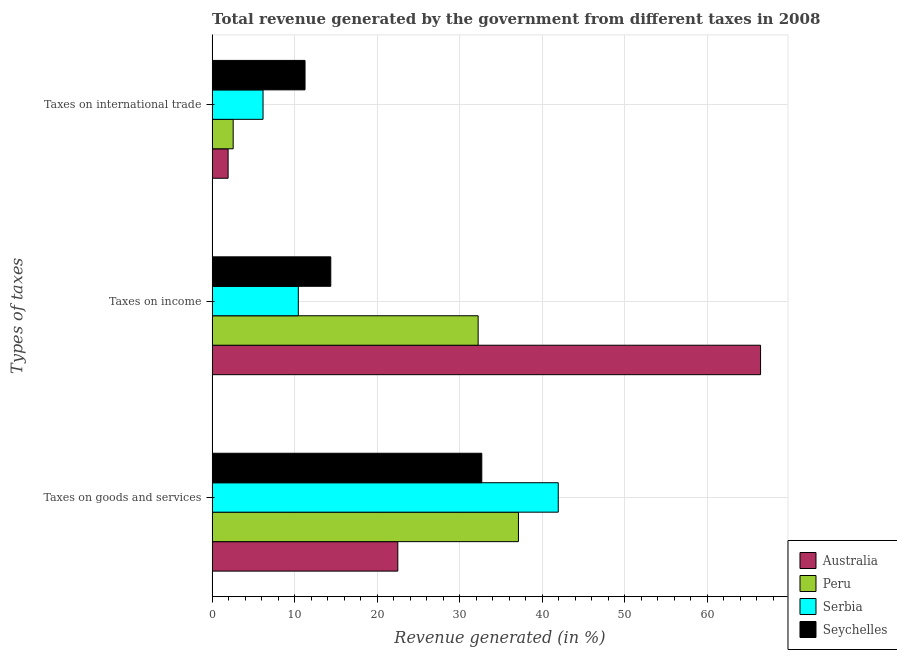How many groups of bars are there?
Your answer should be compact. 3. How many bars are there on the 2nd tick from the top?
Provide a short and direct response. 4. How many bars are there on the 2nd tick from the bottom?
Offer a terse response. 4. What is the label of the 3rd group of bars from the top?
Offer a very short reply. Taxes on goods and services. What is the percentage of revenue generated by tax on international trade in Australia?
Your answer should be very brief. 1.94. Across all countries, what is the maximum percentage of revenue generated by taxes on goods and services?
Ensure brevity in your answer.  41.95. Across all countries, what is the minimum percentage of revenue generated by tax on international trade?
Offer a very short reply. 1.94. In which country was the percentage of revenue generated by tax on international trade maximum?
Your response must be concise. Seychelles. In which country was the percentage of revenue generated by tax on international trade minimum?
Your answer should be compact. Australia. What is the total percentage of revenue generated by taxes on income in the graph?
Ensure brevity in your answer.  123.55. What is the difference between the percentage of revenue generated by taxes on income in Seychelles and that in Serbia?
Your response must be concise. 3.93. What is the difference between the percentage of revenue generated by taxes on goods and services in Peru and the percentage of revenue generated by taxes on income in Seychelles?
Keep it short and to the point. 22.75. What is the average percentage of revenue generated by taxes on income per country?
Offer a very short reply. 30.89. What is the difference between the percentage of revenue generated by taxes on income and percentage of revenue generated by taxes on goods and services in Serbia?
Your answer should be very brief. -31.51. In how many countries, is the percentage of revenue generated by taxes on income greater than 56 %?
Your answer should be very brief. 1. What is the ratio of the percentage of revenue generated by taxes on goods and services in Australia to that in Peru?
Offer a terse response. 0.61. Is the percentage of revenue generated by tax on international trade in Serbia less than that in Seychelles?
Make the answer very short. Yes. What is the difference between the highest and the second highest percentage of revenue generated by tax on international trade?
Provide a succinct answer. 5.09. What is the difference between the highest and the lowest percentage of revenue generated by taxes on goods and services?
Your response must be concise. 19.45. Is the sum of the percentage of revenue generated by taxes on income in Peru and Serbia greater than the maximum percentage of revenue generated by tax on international trade across all countries?
Make the answer very short. Yes. What does the 2nd bar from the top in Taxes on income represents?
Offer a very short reply. Serbia. What does the 1st bar from the bottom in Taxes on income represents?
Make the answer very short. Australia. What is the difference between two consecutive major ticks on the X-axis?
Make the answer very short. 10. Does the graph contain any zero values?
Provide a succinct answer. No. How many legend labels are there?
Your response must be concise. 4. How are the legend labels stacked?
Ensure brevity in your answer.  Vertical. What is the title of the graph?
Ensure brevity in your answer.  Total revenue generated by the government from different taxes in 2008. Does "Korea (Republic)" appear as one of the legend labels in the graph?
Ensure brevity in your answer.  No. What is the label or title of the X-axis?
Your answer should be compact. Revenue generated (in %). What is the label or title of the Y-axis?
Your answer should be compact. Types of taxes. What is the Revenue generated (in %) of Australia in Taxes on goods and services?
Give a very brief answer. 22.51. What is the Revenue generated (in %) of Peru in Taxes on goods and services?
Your answer should be compact. 37.13. What is the Revenue generated (in %) in Serbia in Taxes on goods and services?
Make the answer very short. 41.95. What is the Revenue generated (in %) in Seychelles in Taxes on goods and services?
Give a very brief answer. 32.69. What is the Revenue generated (in %) of Australia in Taxes on income?
Your answer should be compact. 66.48. What is the Revenue generated (in %) of Peru in Taxes on income?
Keep it short and to the point. 32.24. What is the Revenue generated (in %) of Serbia in Taxes on income?
Provide a short and direct response. 10.45. What is the Revenue generated (in %) of Seychelles in Taxes on income?
Give a very brief answer. 14.38. What is the Revenue generated (in %) of Australia in Taxes on international trade?
Your answer should be very brief. 1.94. What is the Revenue generated (in %) of Peru in Taxes on international trade?
Keep it short and to the point. 2.55. What is the Revenue generated (in %) of Serbia in Taxes on international trade?
Ensure brevity in your answer.  6.17. What is the Revenue generated (in %) in Seychelles in Taxes on international trade?
Your response must be concise. 11.26. Across all Types of taxes, what is the maximum Revenue generated (in %) in Australia?
Keep it short and to the point. 66.48. Across all Types of taxes, what is the maximum Revenue generated (in %) in Peru?
Offer a very short reply. 37.13. Across all Types of taxes, what is the maximum Revenue generated (in %) of Serbia?
Make the answer very short. 41.95. Across all Types of taxes, what is the maximum Revenue generated (in %) of Seychelles?
Provide a short and direct response. 32.69. Across all Types of taxes, what is the minimum Revenue generated (in %) of Australia?
Your answer should be very brief. 1.94. Across all Types of taxes, what is the minimum Revenue generated (in %) in Peru?
Provide a succinct answer. 2.55. Across all Types of taxes, what is the minimum Revenue generated (in %) of Serbia?
Offer a very short reply. 6.17. Across all Types of taxes, what is the minimum Revenue generated (in %) of Seychelles?
Make the answer very short. 11.26. What is the total Revenue generated (in %) in Australia in the graph?
Make the answer very short. 90.92. What is the total Revenue generated (in %) in Peru in the graph?
Your answer should be very brief. 71.92. What is the total Revenue generated (in %) of Serbia in the graph?
Give a very brief answer. 58.58. What is the total Revenue generated (in %) of Seychelles in the graph?
Make the answer very short. 58.33. What is the difference between the Revenue generated (in %) of Australia in Taxes on goods and services and that in Taxes on income?
Your answer should be compact. -43.97. What is the difference between the Revenue generated (in %) of Peru in Taxes on goods and services and that in Taxes on income?
Ensure brevity in your answer.  4.89. What is the difference between the Revenue generated (in %) of Serbia in Taxes on goods and services and that in Taxes on income?
Your answer should be very brief. 31.51. What is the difference between the Revenue generated (in %) in Seychelles in Taxes on goods and services and that in Taxes on income?
Offer a very short reply. 18.3. What is the difference between the Revenue generated (in %) of Australia in Taxes on goods and services and that in Taxes on international trade?
Your answer should be very brief. 20.57. What is the difference between the Revenue generated (in %) of Peru in Taxes on goods and services and that in Taxes on international trade?
Offer a very short reply. 34.58. What is the difference between the Revenue generated (in %) of Serbia in Taxes on goods and services and that in Taxes on international trade?
Offer a terse response. 35.78. What is the difference between the Revenue generated (in %) in Seychelles in Taxes on goods and services and that in Taxes on international trade?
Your answer should be compact. 21.43. What is the difference between the Revenue generated (in %) of Australia in Taxes on income and that in Taxes on international trade?
Your response must be concise. 64.54. What is the difference between the Revenue generated (in %) in Peru in Taxes on income and that in Taxes on international trade?
Make the answer very short. 29.69. What is the difference between the Revenue generated (in %) of Serbia in Taxes on income and that in Taxes on international trade?
Make the answer very short. 4.28. What is the difference between the Revenue generated (in %) in Seychelles in Taxes on income and that in Taxes on international trade?
Make the answer very short. 3.12. What is the difference between the Revenue generated (in %) in Australia in Taxes on goods and services and the Revenue generated (in %) in Peru in Taxes on income?
Your answer should be very brief. -9.74. What is the difference between the Revenue generated (in %) of Australia in Taxes on goods and services and the Revenue generated (in %) of Serbia in Taxes on income?
Provide a short and direct response. 12.06. What is the difference between the Revenue generated (in %) of Australia in Taxes on goods and services and the Revenue generated (in %) of Seychelles in Taxes on income?
Offer a very short reply. 8.12. What is the difference between the Revenue generated (in %) in Peru in Taxes on goods and services and the Revenue generated (in %) in Serbia in Taxes on income?
Make the answer very short. 26.68. What is the difference between the Revenue generated (in %) of Peru in Taxes on goods and services and the Revenue generated (in %) of Seychelles in Taxes on income?
Ensure brevity in your answer.  22.75. What is the difference between the Revenue generated (in %) in Serbia in Taxes on goods and services and the Revenue generated (in %) in Seychelles in Taxes on income?
Give a very brief answer. 27.57. What is the difference between the Revenue generated (in %) in Australia in Taxes on goods and services and the Revenue generated (in %) in Peru in Taxes on international trade?
Offer a terse response. 19.96. What is the difference between the Revenue generated (in %) of Australia in Taxes on goods and services and the Revenue generated (in %) of Serbia in Taxes on international trade?
Provide a short and direct response. 16.33. What is the difference between the Revenue generated (in %) of Australia in Taxes on goods and services and the Revenue generated (in %) of Seychelles in Taxes on international trade?
Offer a very short reply. 11.25. What is the difference between the Revenue generated (in %) of Peru in Taxes on goods and services and the Revenue generated (in %) of Serbia in Taxes on international trade?
Give a very brief answer. 30.96. What is the difference between the Revenue generated (in %) in Peru in Taxes on goods and services and the Revenue generated (in %) in Seychelles in Taxes on international trade?
Your answer should be compact. 25.87. What is the difference between the Revenue generated (in %) in Serbia in Taxes on goods and services and the Revenue generated (in %) in Seychelles in Taxes on international trade?
Keep it short and to the point. 30.69. What is the difference between the Revenue generated (in %) in Australia in Taxes on income and the Revenue generated (in %) in Peru in Taxes on international trade?
Give a very brief answer. 63.92. What is the difference between the Revenue generated (in %) of Australia in Taxes on income and the Revenue generated (in %) of Serbia in Taxes on international trade?
Provide a succinct answer. 60.3. What is the difference between the Revenue generated (in %) in Australia in Taxes on income and the Revenue generated (in %) in Seychelles in Taxes on international trade?
Offer a very short reply. 55.21. What is the difference between the Revenue generated (in %) of Peru in Taxes on income and the Revenue generated (in %) of Serbia in Taxes on international trade?
Ensure brevity in your answer.  26.07. What is the difference between the Revenue generated (in %) in Peru in Taxes on income and the Revenue generated (in %) in Seychelles in Taxes on international trade?
Offer a very short reply. 20.98. What is the difference between the Revenue generated (in %) in Serbia in Taxes on income and the Revenue generated (in %) in Seychelles in Taxes on international trade?
Your answer should be compact. -0.81. What is the average Revenue generated (in %) of Australia per Types of taxes?
Provide a succinct answer. 30.31. What is the average Revenue generated (in %) of Peru per Types of taxes?
Ensure brevity in your answer.  23.98. What is the average Revenue generated (in %) in Serbia per Types of taxes?
Provide a succinct answer. 19.53. What is the average Revenue generated (in %) in Seychelles per Types of taxes?
Offer a very short reply. 19.44. What is the difference between the Revenue generated (in %) of Australia and Revenue generated (in %) of Peru in Taxes on goods and services?
Make the answer very short. -14.62. What is the difference between the Revenue generated (in %) in Australia and Revenue generated (in %) in Serbia in Taxes on goods and services?
Provide a short and direct response. -19.45. What is the difference between the Revenue generated (in %) of Australia and Revenue generated (in %) of Seychelles in Taxes on goods and services?
Keep it short and to the point. -10.18. What is the difference between the Revenue generated (in %) in Peru and Revenue generated (in %) in Serbia in Taxes on goods and services?
Your answer should be compact. -4.82. What is the difference between the Revenue generated (in %) in Peru and Revenue generated (in %) in Seychelles in Taxes on goods and services?
Make the answer very short. 4.44. What is the difference between the Revenue generated (in %) of Serbia and Revenue generated (in %) of Seychelles in Taxes on goods and services?
Offer a terse response. 9.27. What is the difference between the Revenue generated (in %) of Australia and Revenue generated (in %) of Peru in Taxes on income?
Offer a very short reply. 34.23. What is the difference between the Revenue generated (in %) of Australia and Revenue generated (in %) of Serbia in Taxes on income?
Your response must be concise. 56.03. What is the difference between the Revenue generated (in %) in Australia and Revenue generated (in %) in Seychelles in Taxes on income?
Offer a terse response. 52.09. What is the difference between the Revenue generated (in %) of Peru and Revenue generated (in %) of Serbia in Taxes on income?
Offer a terse response. 21.79. What is the difference between the Revenue generated (in %) in Peru and Revenue generated (in %) in Seychelles in Taxes on income?
Give a very brief answer. 17.86. What is the difference between the Revenue generated (in %) of Serbia and Revenue generated (in %) of Seychelles in Taxes on income?
Keep it short and to the point. -3.93. What is the difference between the Revenue generated (in %) of Australia and Revenue generated (in %) of Peru in Taxes on international trade?
Provide a succinct answer. -0.61. What is the difference between the Revenue generated (in %) of Australia and Revenue generated (in %) of Serbia in Taxes on international trade?
Provide a short and direct response. -4.23. What is the difference between the Revenue generated (in %) in Australia and Revenue generated (in %) in Seychelles in Taxes on international trade?
Your answer should be very brief. -9.32. What is the difference between the Revenue generated (in %) of Peru and Revenue generated (in %) of Serbia in Taxes on international trade?
Your response must be concise. -3.62. What is the difference between the Revenue generated (in %) of Peru and Revenue generated (in %) of Seychelles in Taxes on international trade?
Ensure brevity in your answer.  -8.71. What is the difference between the Revenue generated (in %) of Serbia and Revenue generated (in %) of Seychelles in Taxes on international trade?
Your response must be concise. -5.09. What is the ratio of the Revenue generated (in %) in Australia in Taxes on goods and services to that in Taxes on income?
Ensure brevity in your answer.  0.34. What is the ratio of the Revenue generated (in %) in Peru in Taxes on goods and services to that in Taxes on income?
Your answer should be compact. 1.15. What is the ratio of the Revenue generated (in %) in Serbia in Taxes on goods and services to that in Taxes on income?
Provide a succinct answer. 4.02. What is the ratio of the Revenue generated (in %) in Seychelles in Taxes on goods and services to that in Taxes on income?
Make the answer very short. 2.27. What is the ratio of the Revenue generated (in %) of Australia in Taxes on goods and services to that in Taxes on international trade?
Provide a succinct answer. 11.61. What is the ratio of the Revenue generated (in %) in Peru in Taxes on goods and services to that in Taxes on international trade?
Make the answer very short. 14.56. What is the ratio of the Revenue generated (in %) in Serbia in Taxes on goods and services to that in Taxes on international trade?
Provide a short and direct response. 6.8. What is the ratio of the Revenue generated (in %) in Seychelles in Taxes on goods and services to that in Taxes on international trade?
Provide a short and direct response. 2.9. What is the ratio of the Revenue generated (in %) of Australia in Taxes on income to that in Taxes on international trade?
Give a very brief answer. 34.3. What is the ratio of the Revenue generated (in %) in Peru in Taxes on income to that in Taxes on international trade?
Keep it short and to the point. 12.64. What is the ratio of the Revenue generated (in %) of Serbia in Taxes on income to that in Taxes on international trade?
Your response must be concise. 1.69. What is the ratio of the Revenue generated (in %) in Seychelles in Taxes on income to that in Taxes on international trade?
Keep it short and to the point. 1.28. What is the difference between the highest and the second highest Revenue generated (in %) of Australia?
Provide a succinct answer. 43.97. What is the difference between the highest and the second highest Revenue generated (in %) of Peru?
Your answer should be compact. 4.89. What is the difference between the highest and the second highest Revenue generated (in %) in Serbia?
Offer a terse response. 31.51. What is the difference between the highest and the second highest Revenue generated (in %) of Seychelles?
Make the answer very short. 18.3. What is the difference between the highest and the lowest Revenue generated (in %) of Australia?
Ensure brevity in your answer.  64.54. What is the difference between the highest and the lowest Revenue generated (in %) of Peru?
Offer a very short reply. 34.58. What is the difference between the highest and the lowest Revenue generated (in %) in Serbia?
Offer a terse response. 35.78. What is the difference between the highest and the lowest Revenue generated (in %) in Seychelles?
Give a very brief answer. 21.43. 